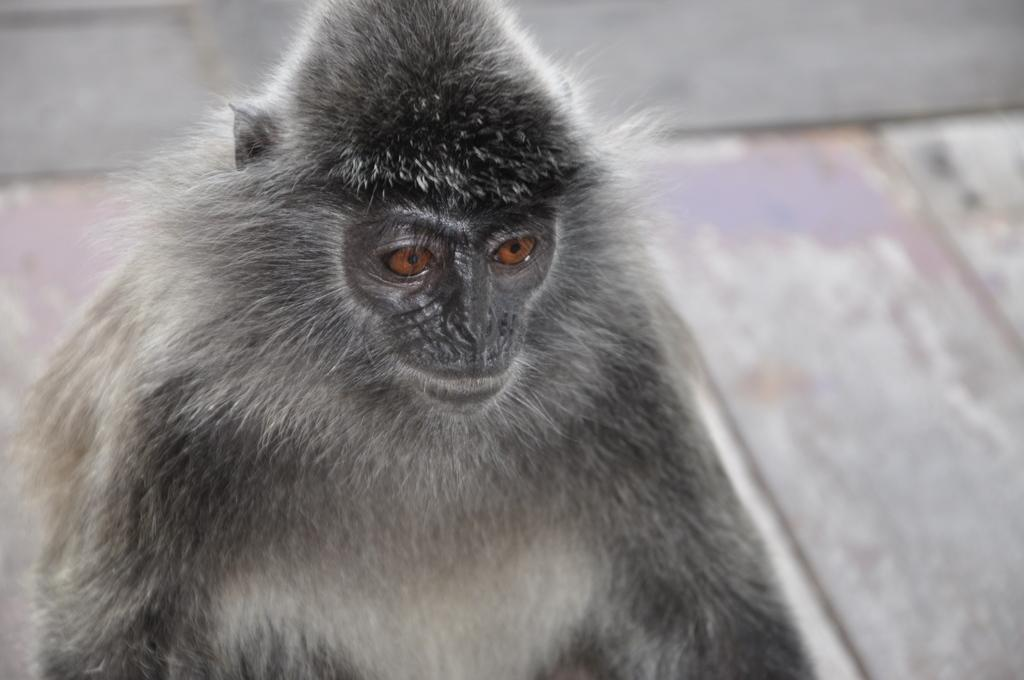What is the main subject in the center of the image? There is a monkey in the center of the image. What is located at the bottom of the image? There is a floor at the bottom of the image. What type of print can be seen on the cow in the image? There is no cow present in the image; it features a monkey. What time of day is it in the image? The time of day is not mentioned or depicted in the image. 